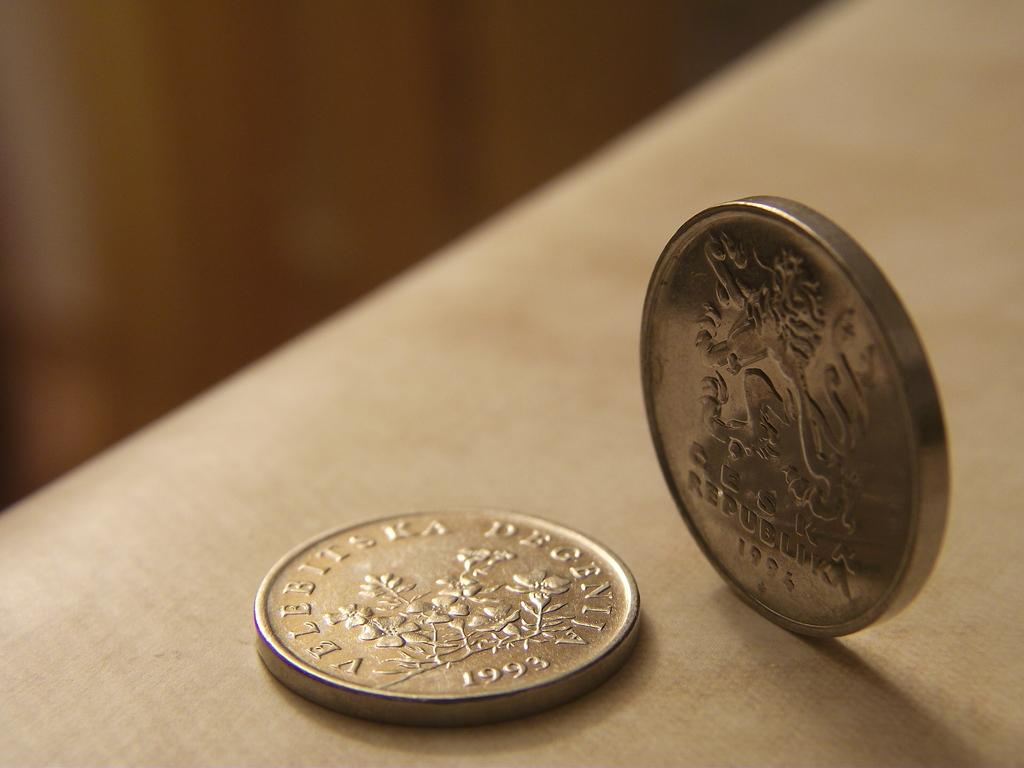<image>
Present a compact description of the photo's key features. A foreign coin from 1993 with the words Velebitska Degenija on it. 